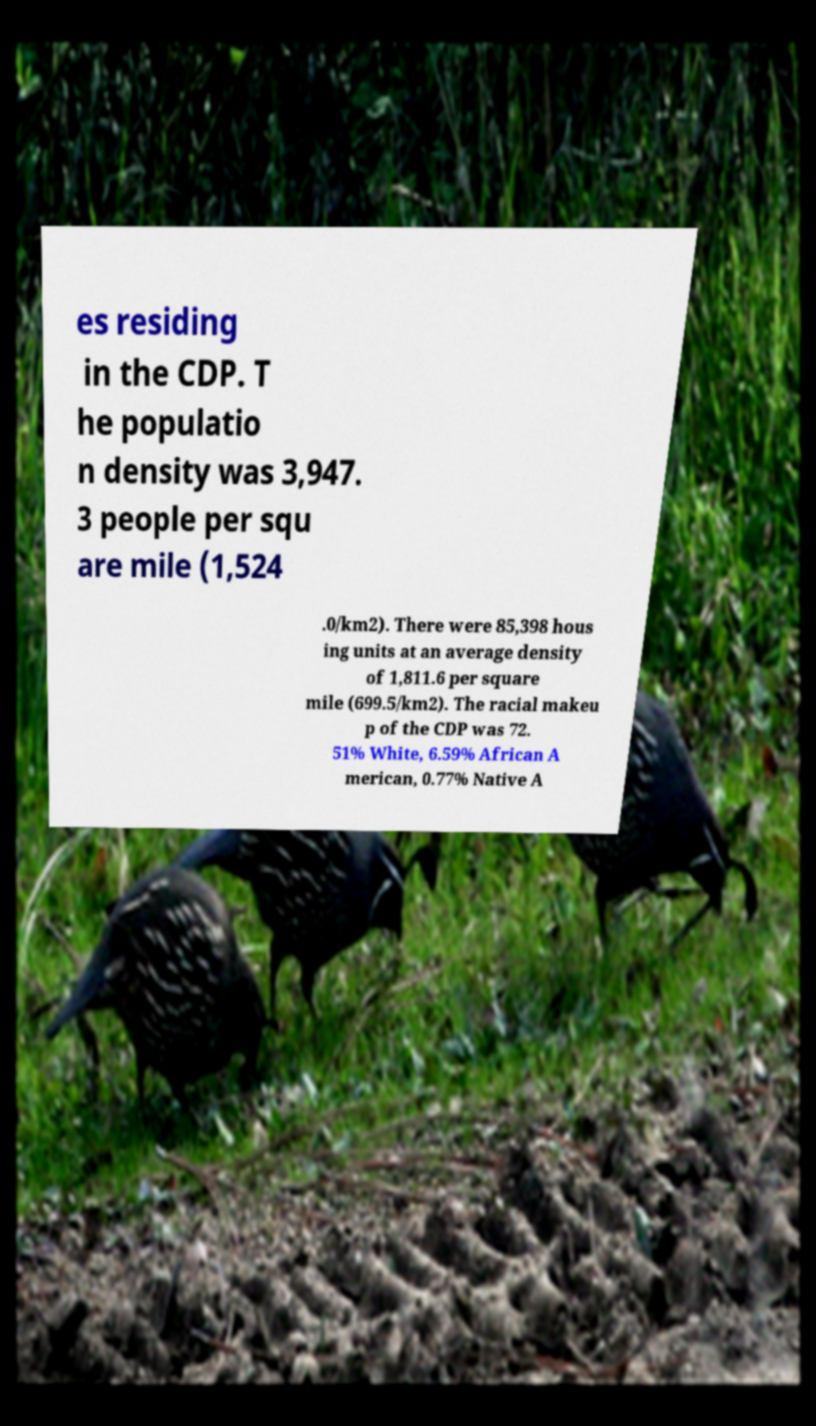Could you extract and type out the text from this image? es residing in the CDP. T he populatio n density was 3,947. 3 people per squ are mile (1,524 .0/km2). There were 85,398 hous ing units at an average density of 1,811.6 per square mile (699.5/km2). The racial makeu p of the CDP was 72. 51% White, 6.59% African A merican, 0.77% Native A 